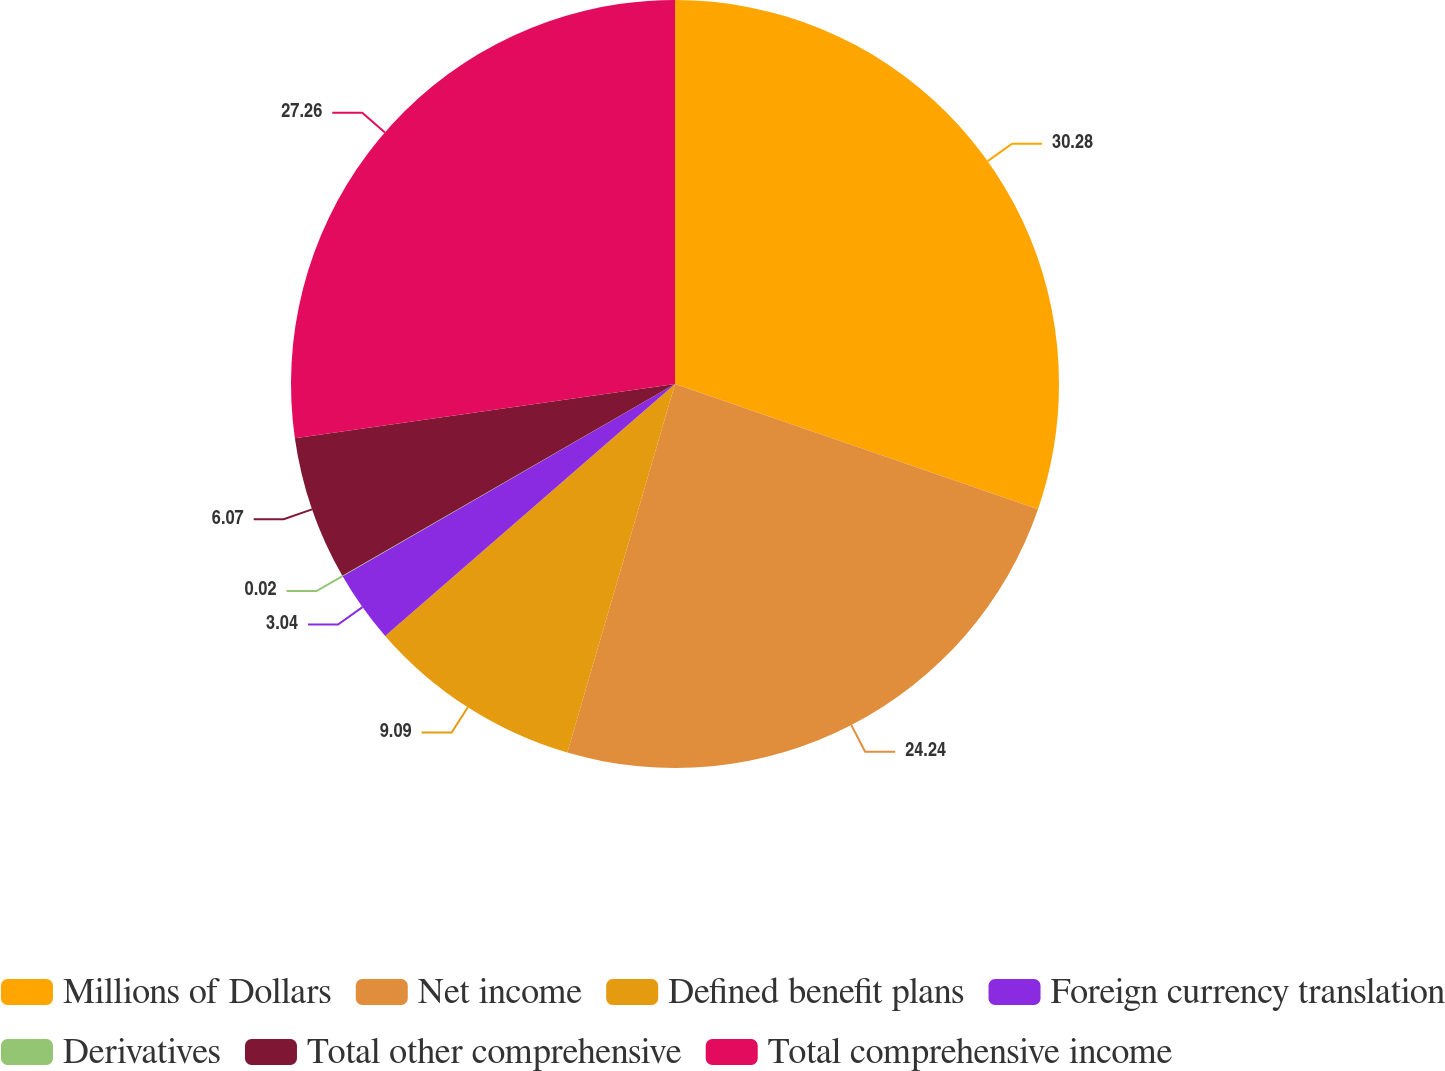Convert chart. <chart><loc_0><loc_0><loc_500><loc_500><pie_chart><fcel>Millions of Dollars<fcel>Net income<fcel>Defined benefit plans<fcel>Foreign currency translation<fcel>Derivatives<fcel>Total other comprehensive<fcel>Total comprehensive income<nl><fcel>30.29%<fcel>24.24%<fcel>9.09%<fcel>3.04%<fcel>0.02%<fcel>6.07%<fcel>27.26%<nl></chart> 